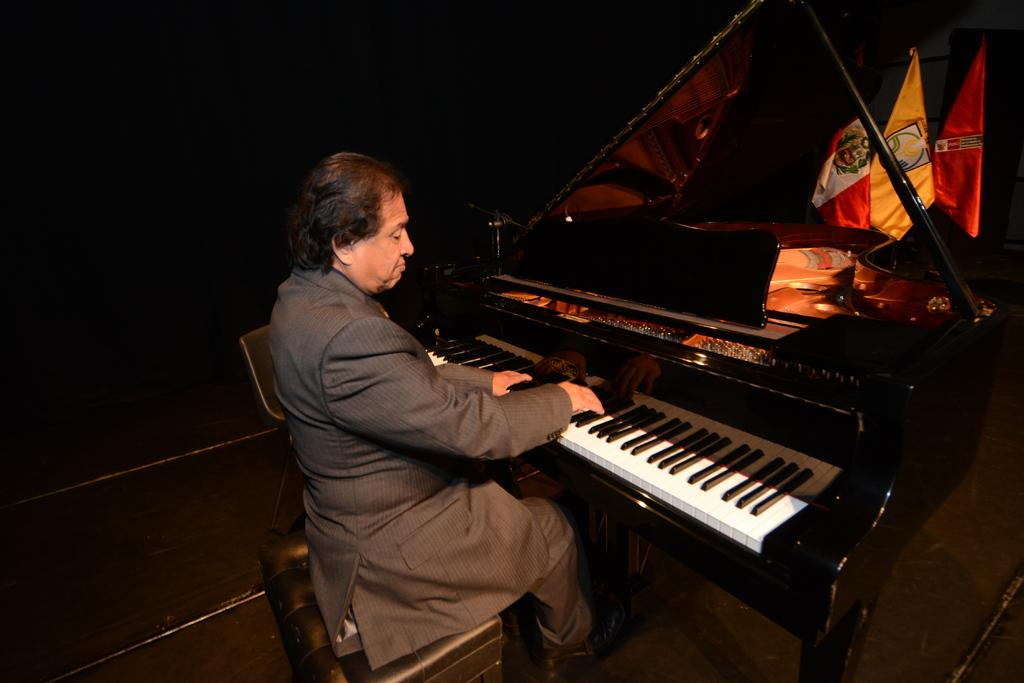Who is the person in the image? There is a man in the image. What is the man doing in the image? The man is sitting on a chair and playing a piano. What can be seen in front of the man? There are various flags present in front of the man. What type of comb is the toad using to play the guitar in the image? There is no toad or guitar present in the image. The man is playing a piano, and there are flags in front of him. 